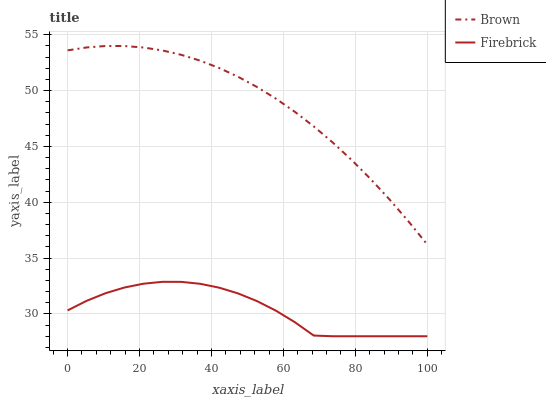Does Firebrick have the minimum area under the curve?
Answer yes or no. Yes. Does Brown have the maximum area under the curve?
Answer yes or no. Yes. Does Firebrick have the maximum area under the curve?
Answer yes or no. No. Is Brown the smoothest?
Answer yes or no. Yes. Is Firebrick the roughest?
Answer yes or no. Yes. Is Firebrick the smoothest?
Answer yes or no. No. Does Firebrick have the lowest value?
Answer yes or no. Yes. Does Brown have the highest value?
Answer yes or no. Yes. Does Firebrick have the highest value?
Answer yes or no. No. Is Firebrick less than Brown?
Answer yes or no. Yes. Is Brown greater than Firebrick?
Answer yes or no. Yes. Does Firebrick intersect Brown?
Answer yes or no. No. 